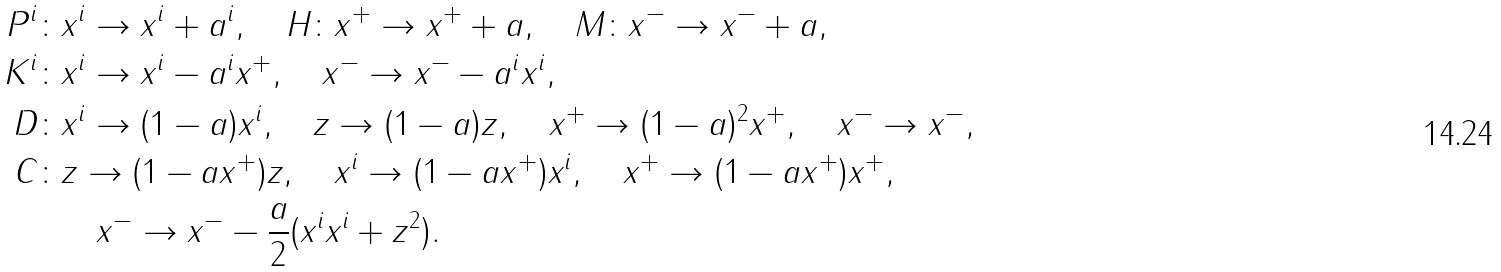Convert formula to latex. <formula><loc_0><loc_0><loc_500><loc_500>P ^ { i } \colon & x ^ { i } \to x ^ { i } + a ^ { i } , \quad H \colon x ^ { + } \to x ^ { + } + a , \quad M \colon x ^ { - } \to x ^ { - } + a , \\ K ^ { i } \colon & x ^ { i } \to x ^ { i } - a ^ { i } x ^ { + } , \quad x ^ { - } \to x ^ { - } - a ^ { i } x ^ { i } , \\ D \colon & x ^ { i } \to ( 1 - a ) x ^ { i } , \quad z \to ( 1 - a ) z , \quad x ^ { + } \to ( 1 - a ) ^ { 2 } x ^ { + } , \quad x ^ { - } \to x ^ { - } , \\ C \colon & z \to ( 1 - a x ^ { + } ) z , \quad x ^ { i } \to ( 1 - a x ^ { + } ) x ^ { i } , \quad x ^ { + } \to ( 1 - a x ^ { + } ) x ^ { + } , \\ \ & \quad x ^ { - } \to x ^ { - } - \frac { a } { 2 } ( x ^ { i } x ^ { i } + z ^ { 2 } ) .</formula> 